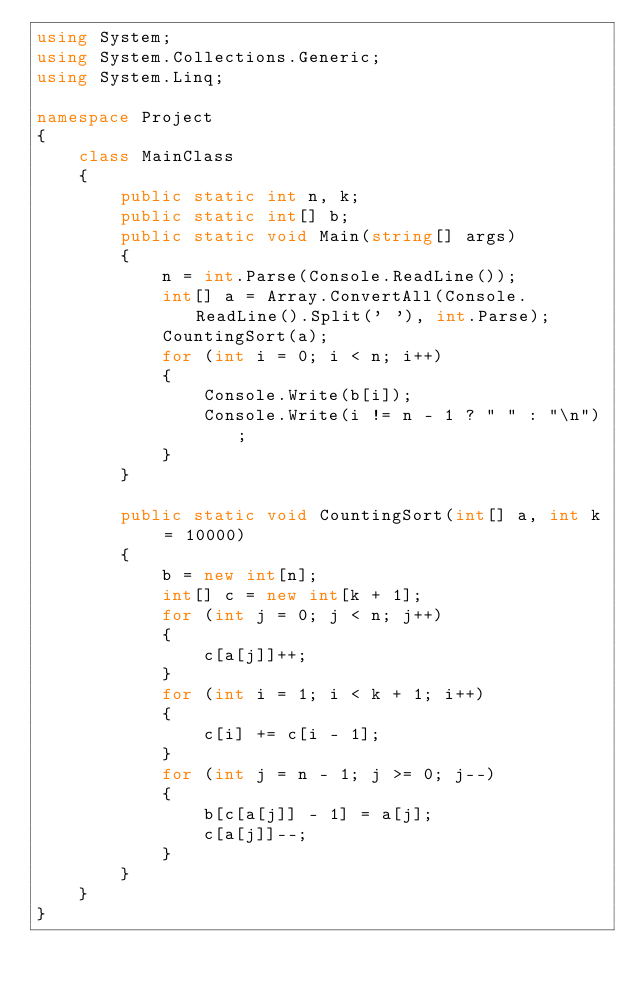Convert code to text. <code><loc_0><loc_0><loc_500><loc_500><_C#_>using System;
using System.Collections.Generic;
using System.Linq;

namespace Project
{
	class MainClass
	{
		public static int n, k;
		public static int[] b;
		public static void Main(string[] args)
		{
			n = int.Parse(Console.ReadLine());
			int[] a = Array.ConvertAll(Console.ReadLine().Split(' '), int.Parse);
			CountingSort(a);
			for (int i = 0; i < n; i++)
			{
				Console.Write(b[i]);
				Console.Write(i != n - 1 ? " " : "\n");
			}
		}

		public static void CountingSort(int[] a, int k = 10000)
		{
			b = new int[n];
			int[] c = new int[k + 1];
			for (int j = 0; j < n; j++)
			{
				c[a[j]]++;
			}
			for (int i = 1; i < k + 1; i++)
			{
				c[i] += c[i - 1];
			}
			for (int j = n - 1; j >= 0; j--)
			{
				b[c[a[j]] - 1] = a[j];
				c[a[j]]--;
			}
		}
	}
}</code> 